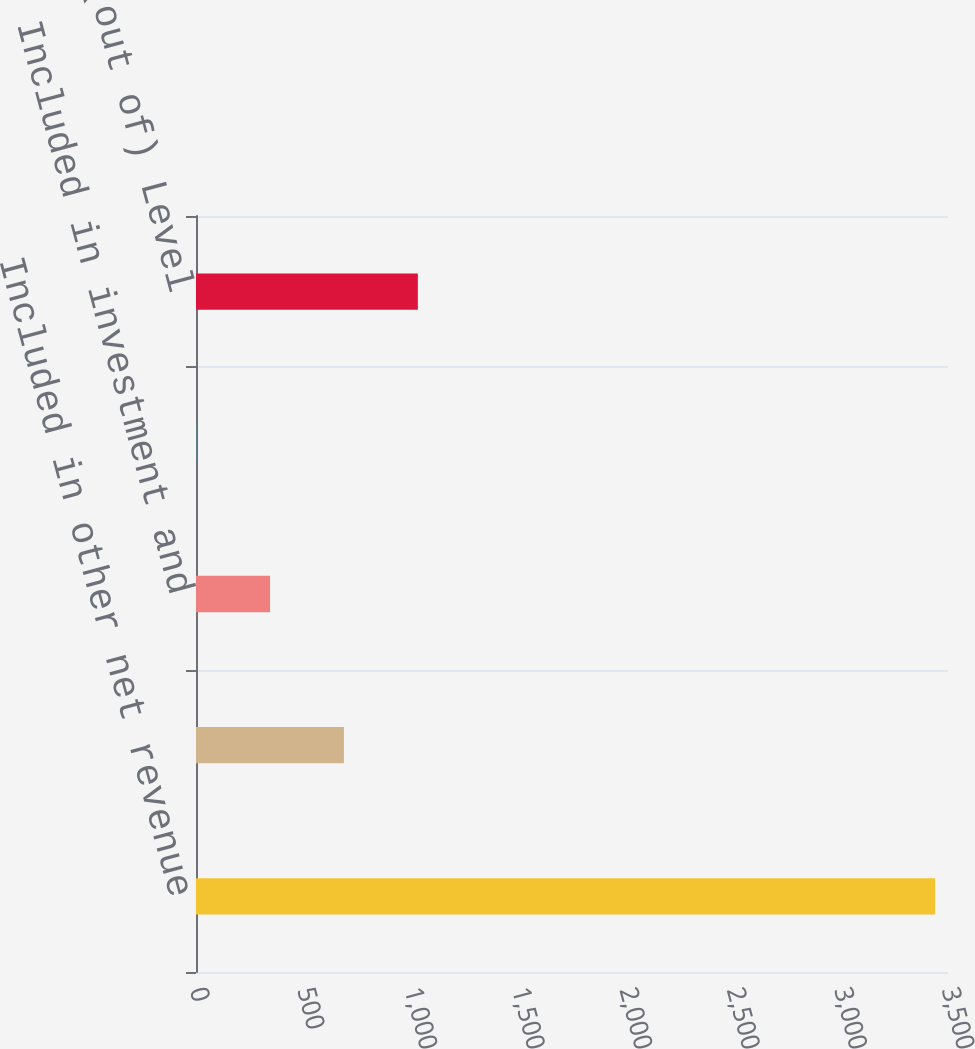Convert chart. <chart><loc_0><loc_0><loc_500><loc_500><bar_chart><fcel>Included in other net revenue<fcel>Included in consolidated<fcel>Included in investment and<fcel>Included in accumulated other<fcel>Transfers into/(out of) Level<nl><fcel>3440<fcel>688.55<fcel>344.62<fcel>0.69<fcel>1032.48<nl></chart> 